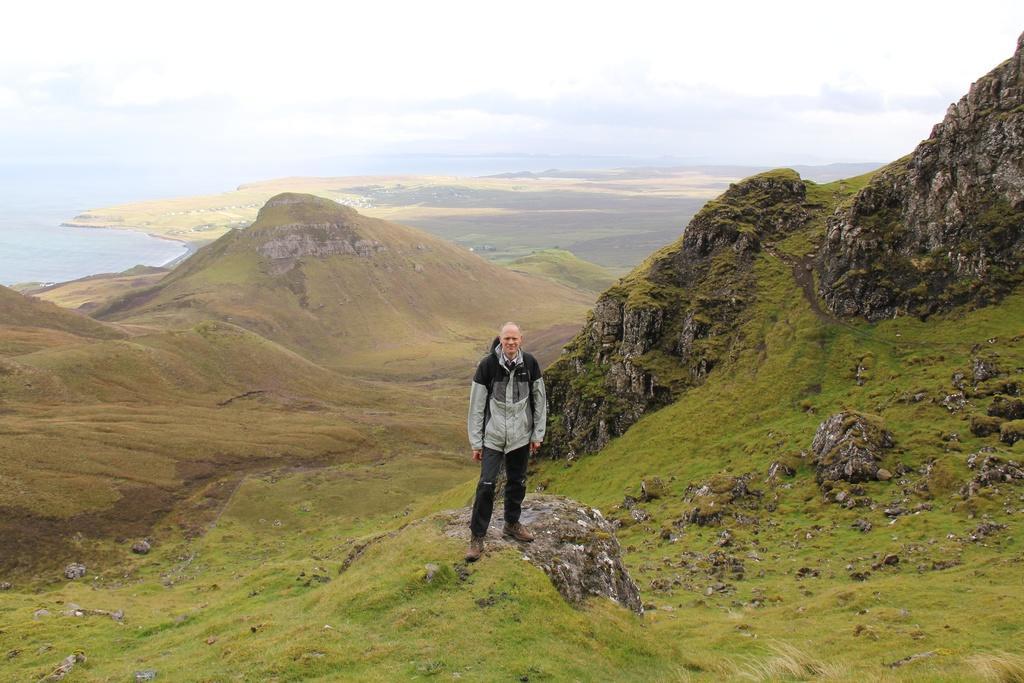Could you give a brief overview of what you see in this image? In the picture we can see a man standing on the hill surface and behind him we can see the hills, water surface and the sky with clouds. 